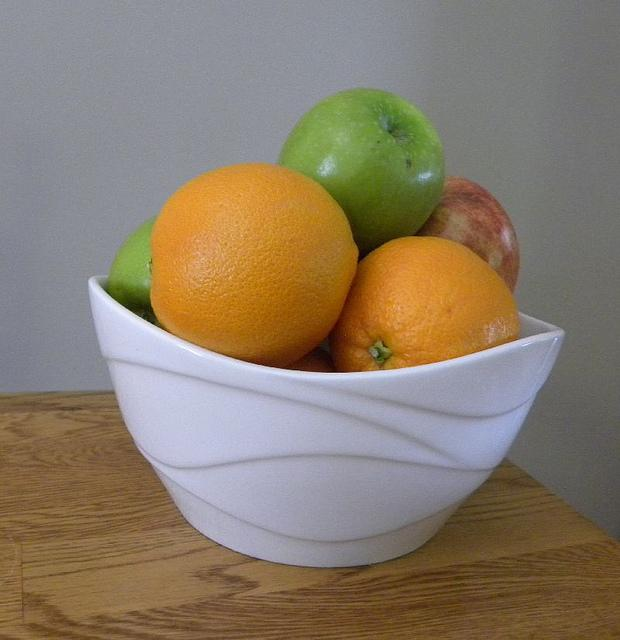What color skin does the tartest fruit seen here have? Please explain your reasoning. green. Green apples are more tart. 